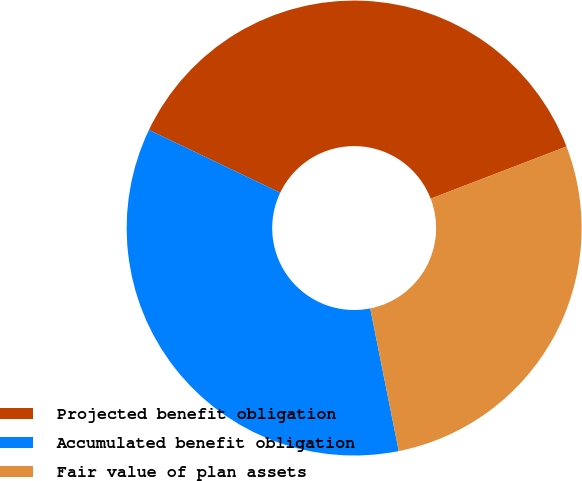Convert chart to OTSL. <chart><loc_0><loc_0><loc_500><loc_500><pie_chart><fcel>Projected benefit obligation<fcel>Accumulated benefit obligation<fcel>Fair value of plan assets<nl><fcel>37.07%<fcel>35.24%<fcel>27.69%<nl></chart> 